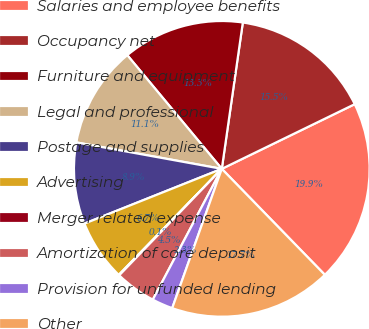Convert chart to OTSL. <chart><loc_0><loc_0><loc_500><loc_500><pie_chart><fcel>Salaries and employee benefits<fcel>Occupancy net<fcel>Furniture and equipment<fcel>Legal and professional<fcel>Postage and supplies<fcel>Advertising<fcel>Merger related expense<fcel>Amortization of core deposit<fcel>Provision for unfunded lending<fcel>Other<nl><fcel>19.93%<fcel>15.52%<fcel>13.31%<fcel>11.1%<fcel>8.9%<fcel>6.69%<fcel>0.07%<fcel>4.48%<fcel>2.28%<fcel>17.72%<nl></chart> 